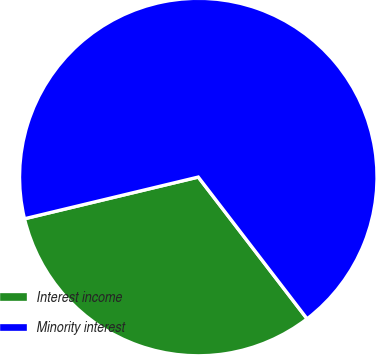Convert chart. <chart><loc_0><loc_0><loc_500><loc_500><pie_chart><fcel>Interest income<fcel>Minority interest<nl><fcel>31.67%<fcel>68.33%<nl></chart> 